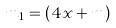Convert formula to latex. <formula><loc_0><loc_0><loc_500><loc_500>m _ { 1 } = ( 4 x + m )</formula> 